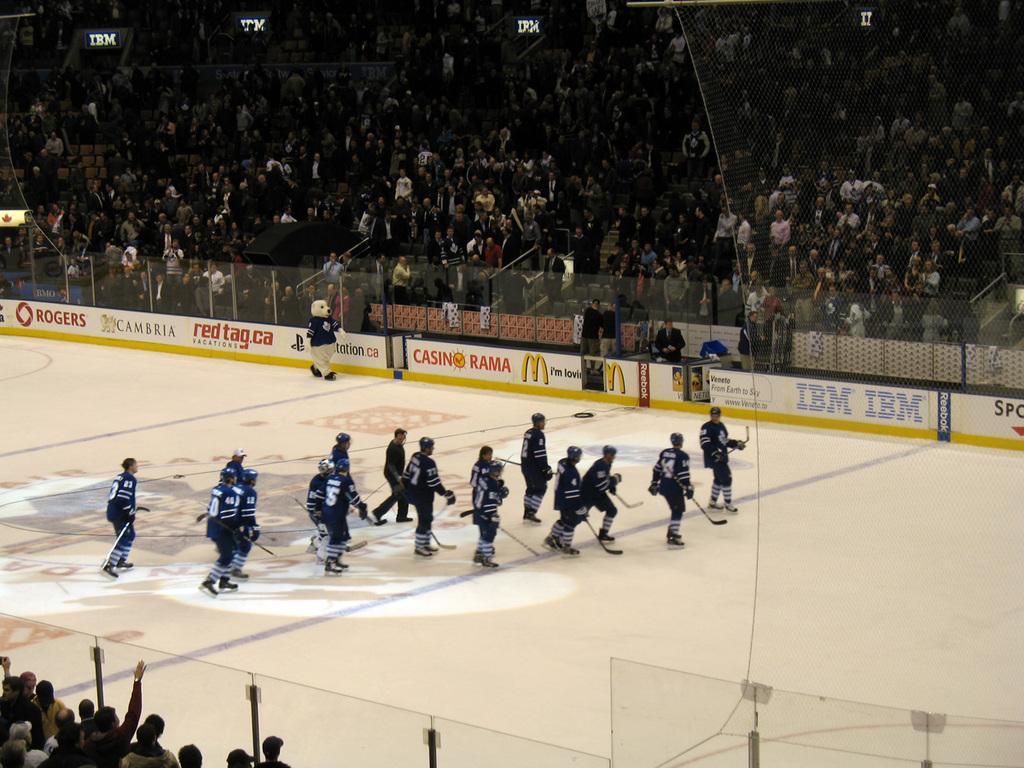Please provide a concise description of this image. in this image in the front there are persons and there is a glass. In the middle there are persons skating. In the background there are boards with some text written on it and there is a fence and there are group of persons standing and sitting and there is a person wearing costume of an animal. 